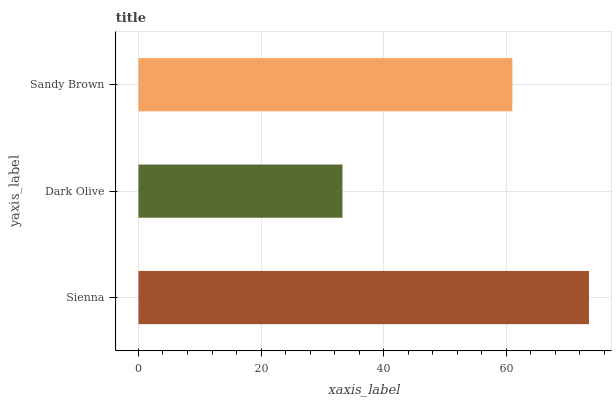Is Dark Olive the minimum?
Answer yes or no. Yes. Is Sienna the maximum?
Answer yes or no. Yes. Is Sandy Brown the minimum?
Answer yes or no. No. Is Sandy Brown the maximum?
Answer yes or no. No. Is Sandy Brown greater than Dark Olive?
Answer yes or no. Yes. Is Dark Olive less than Sandy Brown?
Answer yes or no. Yes. Is Dark Olive greater than Sandy Brown?
Answer yes or no. No. Is Sandy Brown less than Dark Olive?
Answer yes or no. No. Is Sandy Brown the high median?
Answer yes or no. Yes. Is Sandy Brown the low median?
Answer yes or no. Yes. Is Dark Olive the high median?
Answer yes or no. No. Is Sienna the low median?
Answer yes or no. No. 